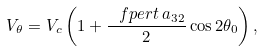<formula> <loc_0><loc_0><loc_500><loc_500>V _ { \theta } = V _ { c } \left ( 1 + \frac { \ f p e r t \, a _ { 3 2 } } { 2 } \cos 2 \theta _ { 0 } \right ) ,</formula> 